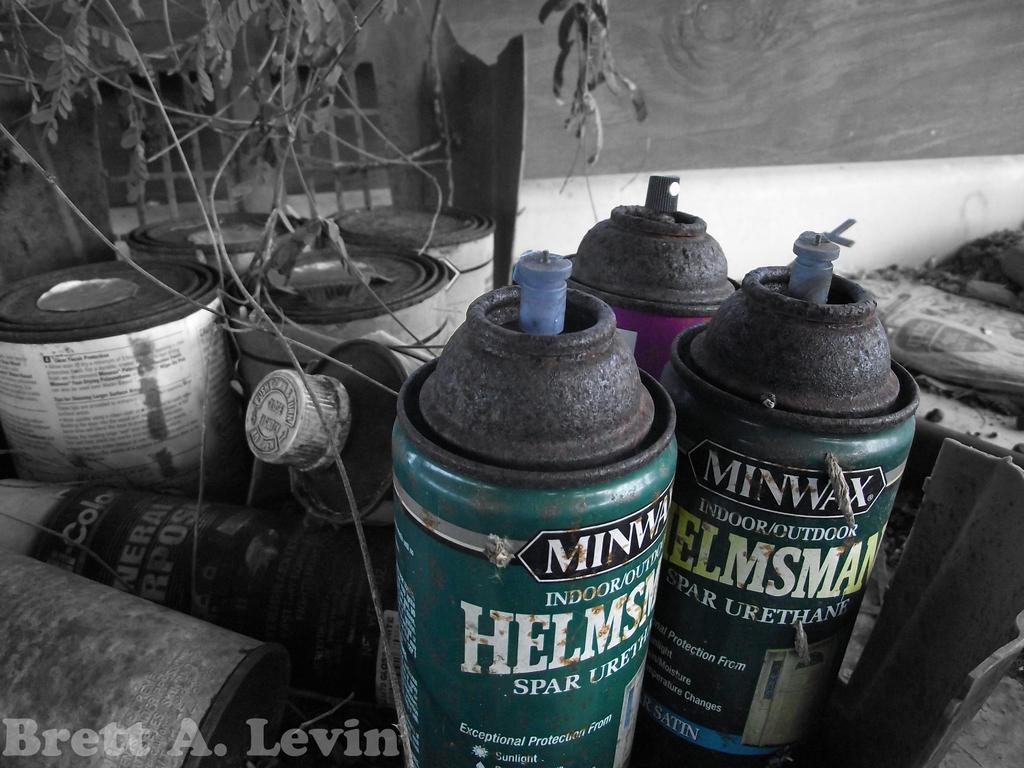What brand of paint?
Keep it short and to the point. Minwax. 